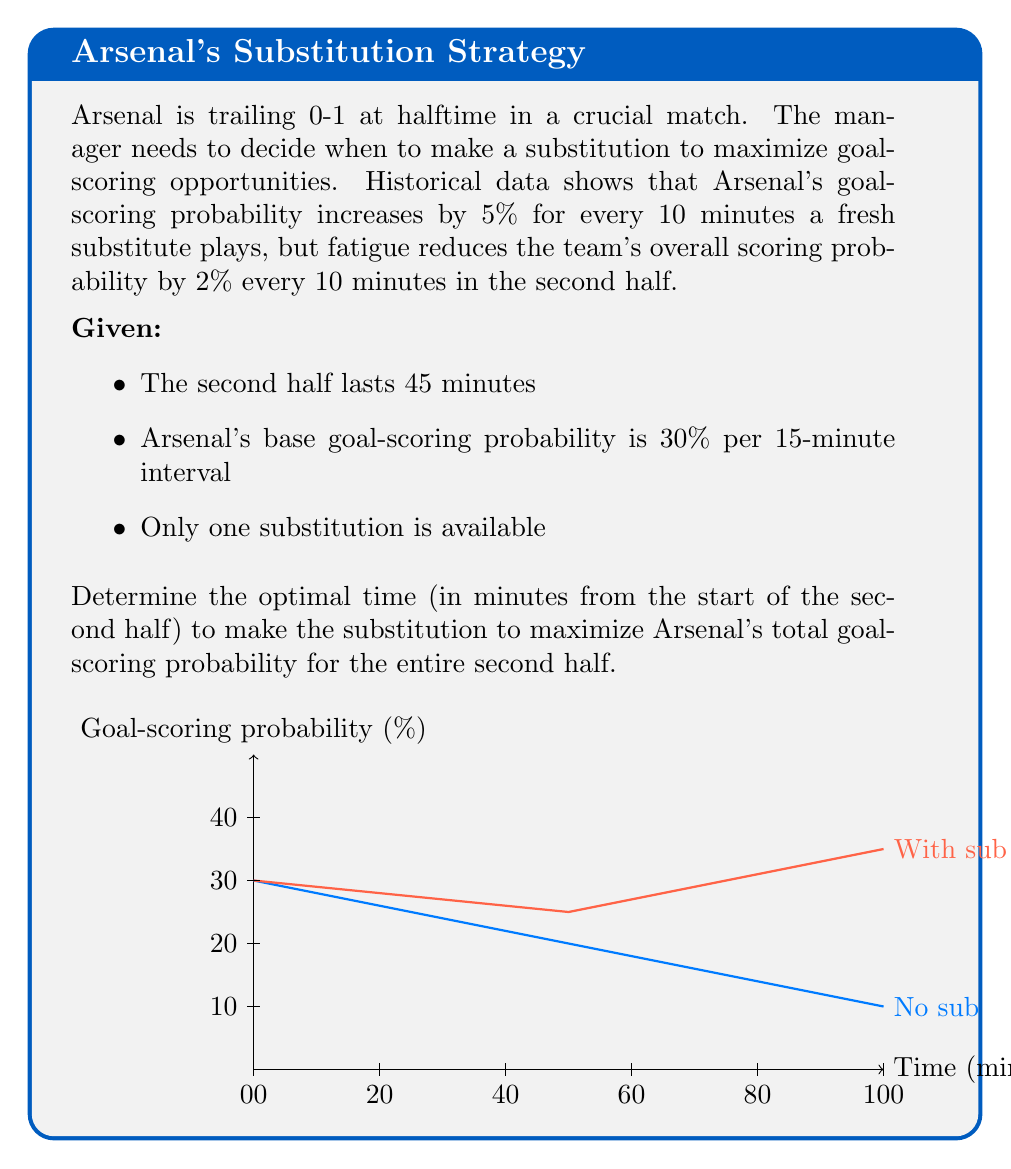Solve this math problem. Let's approach this step-by-step:

1) First, let's define our variables:
   $t$ = time of substitution (in minutes from start of second half)
   $P(t)$ = total goal-scoring probability for the second half

2) We need to consider two periods: before and after the substitution.

3) Before substitution (0 to $t$ minutes):
   Probability decreases by 2% every 10 minutes.
   Rate of decrease: $0.002$ per minute
   Probability at time $t$: $0.30 - 0.002t$

4) After substitution ($t$ to 45 minutes):
   Probability increases by 5% every 10 minutes due to the sub.
   Rate of increase: $0.005$ per minute
   But it still decreases by $0.002$ per minute due to fatigue.
   Net rate of increase: $0.003$ per minute
   Probability at 45 minutes: $(0.30 - 0.002t) + 0.003(45-t)$

5) To calculate total probability, we integrate over the two periods:

   $$P(t) = \int_0^t (0.30 - 0.002x) dx + \int_t^{45} ((0.30 - 0.002t) + 0.003(x-t)) dx$$

6) Solving the integrals:

   $$P(t) = [0.30x - 0.001x^2]_0^t + [(0.30 - 0.002t)x + 0.0015x^2 - 0.003tx]_t^{45}$$

7) Simplify:

   $$P(t) = 0.30t - 0.001t^2 + 13.5 - 0.09t + 3.0375 - 0.135t + 0.001t^2$$

   $$P(t) = 16.5375 - 0.225t$$

8) To find the maximum, we differentiate and set to zero:

   $$\frac{dP}{dt} = -0.225 = 0$$

9) This is always negative, meaning $P(t)$ is always decreasing. Therefore, the maximum occurs at the earliest possible time, $t = 0$.
Answer: 0 minutes (immediate substitution at halftime) 